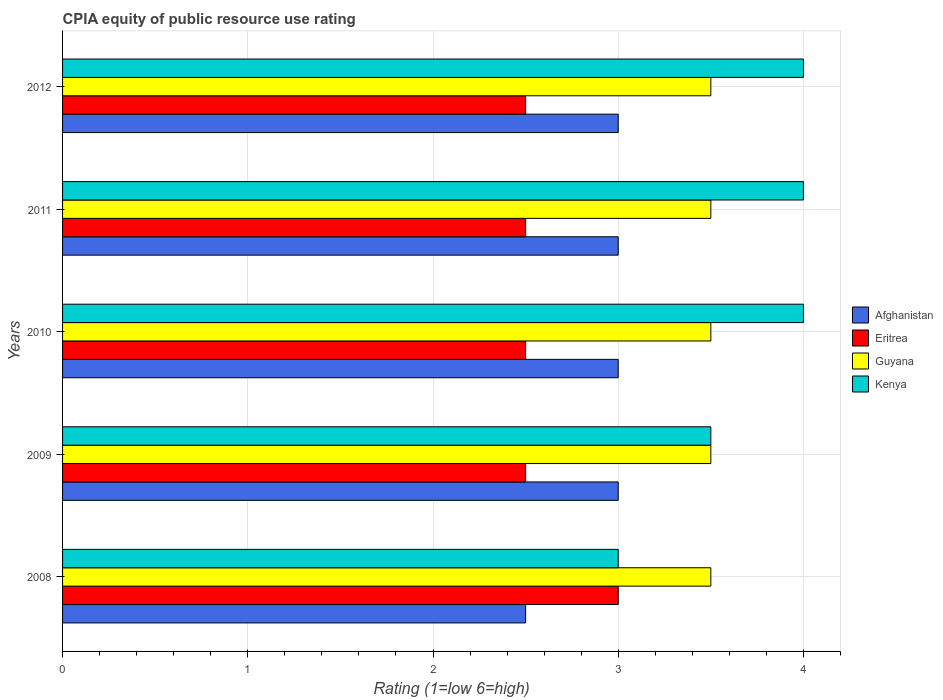How many groups of bars are there?
Provide a short and direct response. 5. Are the number of bars per tick equal to the number of legend labels?
Provide a succinct answer. Yes. What is the label of the 3rd group of bars from the top?
Ensure brevity in your answer.  2010. In how many cases, is the number of bars for a given year not equal to the number of legend labels?
Your response must be concise. 0. Across all years, what is the maximum CPIA rating in Guyana?
Provide a short and direct response. 3.5. In which year was the CPIA rating in Afghanistan minimum?
Your answer should be compact. 2008. What is the difference between the CPIA rating in Guyana in 2010 and the CPIA rating in Eritrea in 2008?
Provide a succinct answer. 0.5. In the year 2008, what is the difference between the CPIA rating in Guyana and CPIA rating in Kenya?
Your response must be concise. 0.5. What is the difference between the highest and the lowest CPIA rating in Kenya?
Ensure brevity in your answer.  1. Is the sum of the CPIA rating in Guyana in 2010 and 2011 greater than the maximum CPIA rating in Afghanistan across all years?
Your answer should be compact. Yes. What does the 2nd bar from the top in 2008 represents?
Offer a terse response. Guyana. What does the 2nd bar from the bottom in 2012 represents?
Your answer should be very brief. Eritrea. Is it the case that in every year, the sum of the CPIA rating in Eritrea and CPIA rating in Afghanistan is greater than the CPIA rating in Guyana?
Your answer should be very brief. Yes. What is the difference between two consecutive major ticks on the X-axis?
Ensure brevity in your answer.  1. Does the graph contain grids?
Your response must be concise. Yes. What is the title of the graph?
Your answer should be compact. CPIA equity of public resource use rating. What is the label or title of the Y-axis?
Keep it short and to the point. Years. What is the Rating (1=low 6=high) of Afghanistan in 2008?
Offer a terse response. 2.5. What is the Rating (1=low 6=high) in Eritrea in 2008?
Your answer should be compact. 3. What is the Rating (1=low 6=high) of Guyana in 2009?
Provide a succinct answer. 3.5. What is the Rating (1=low 6=high) of Guyana in 2010?
Offer a very short reply. 3.5. What is the Rating (1=low 6=high) in Guyana in 2011?
Ensure brevity in your answer.  3.5. What is the Rating (1=low 6=high) in Kenya in 2011?
Ensure brevity in your answer.  4. What is the Rating (1=low 6=high) in Afghanistan in 2012?
Provide a short and direct response. 3. What is the Rating (1=low 6=high) in Eritrea in 2012?
Give a very brief answer. 2.5. What is the Rating (1=low 6=high) of Guyana in 2012?
Provide a short and direct response. 3.5. Across all years, what is the maximum Rating (1=low 6=high) of Afghanistan?
Give a very brief answer. 3. Across all years, what is the minimum Rating (1=low 6=high) of Guyana?
Offer a very short reply. 3.5. Across all years, what is the minimum Rating (1=low 6=high) in Kenya?
Give a very brief answer. 3. What is the total Rating (1=low 6=high) of Afghanistan in the graph?
Offer a terse response. 14.5. What is the total Rating (1=low 6=high) in Eritrea in the graph?
Your response must be concise. 13. What is the difference between the Rating (1=low 6=high) in Afghanistan in 2008 and that in 2009?
Provide a succinct answer. -0.5. What is the difference between the Rating (1=low 6=high) in Kenya in 2008 and that in 2009?
Your answer should be compact. -0.5. What is the difference between the Rating (1=low 6=high) in Eritrea in 2008 and that in 2010?
Provide a short and direct response. 0.5. What is the difference between the Rating (1=low 6=high) of Kenya in 2008 and that in 2010?
Your answer should be compact. -1. What is the difference between the Rating (1=low 6=high) in Afghanistan in 2008 and that in 2011?
Offer a terse response. -0.5. What is the difference between the Rating (1=low 6=high) of Eritrea in 2008 and that in 2011?
Offer a very short reply. 0.5. What is the difference between the Rating (1=low 6=high) in Guyana in 2008 and that in 2011?
Ensure brevity in your answer.  0. What is the difference between the Rating (1=low 6=high) of Kenya in 2008 and that in 2011?
Give a very brief answer. -1. What is the difference between the Rating (1=low 6=high) in Afghanistan in 2009 and that in 2011?
Give a very brief answer. 0. What is the difference between the Rating (1=low 6=high) of Guyana in 2009 and that in 2011?
Your answer should be compact. 0. What is the difference between the Rating (1=low 6=high) in Afghanistan in 2010 and that in 2011?
Ensure brevity in your answer.  0. What is the difference between the Rating (1=low 6=high) in Eritrea in 2010 and that in 2011?
Keep it short and to the point. 0. What is the difference between the Rating (1=low 6=high) of Guyana in 2010 and that in 2011?
Make the answer very short. 0. What is the difference between the Rating (1=low 6=high) of Kenya in 2010 and that in 2011?
Keep it short and to the point. 0. What is the difference between the Rating (1=low 6=high) in Afghanistan in 2010 and that in 2012?
Provide a succinct answer. 0. What is the difference between the Rating (1=low 6=high) in Guyana in 2010 and that in 2012?
Ensure brevity in your answer.  0. What is the difference between the Rating (1=low 6=high) in Kenya in 2010 and that in 2012?
Offer a very short reply. 0. What is the difference between the Rating (1=low 6=high) in Afghanistan in 2011 and that in 2012?
Your answer should be compact. 0. What is the difference between the Rating (1=low 6=high) of Eritrea in 2011 and that in 2012?
Offer a very short reply. 0. What is the difference between the Rating (1=low 6=high) of Afghanistan in 2008 and the Rating (1=low 6=high) of Eritrea in 2009?
Your answer should be compact. 0. What is the difference between the Rating (1=low 6=high) of Eritrea in 2008 and the Rating (1=low 6=high) of Guyana in 2009?
Your response must be concise. -0.5. What is the difference between the Rating (1=low 6=high) of Afghanistan in 2008 and the Rating (1=low 6=high) of Guyana in 2010?
Offer a terse response. -1. What is the difference between the Rating (1=low 6=high) in Eritrea in 2008 and the Rating (1=low 6=high) in Kenya in 2010?
Provide a succinct answer. -1. What is the difference between the Rating (1=low 6=high) in Guyana in 2008 and the Rating (1=low 6=high) in Kenya in 2010?
Offer a terse response. -0.5. What is the difference between the Rating (1=low 6=high) of Afghanistan in 2008 and the Rating (1=low 6=high) of Eritrea in 2011?
Provide a succinct answer. 0. What is the difference between the Rating (1=low 6=high) of Afghanistan in 2008 and the Rating (1=low 6=high) of Eritrea in 2012?
Your response must be concise. 0. What is the difference between the Rating (1=low 6=high) in Afghanistan in 2008 and the Rating (1=low 6=high) in Kenya in 2012?
Make the answer very short. -1.5. What is the difference between the Rating (1=low 6=high) of Eritrea in 2008 and the Rating (1=low 6=high) of Guyana in 2012?
Your answer should be very brief. -0.5. What is the difference between the Rating (1=low 6=high) of Eritrea in 2008 and the Rating (1=low 6=high) of Kenya in 2012?
Your response must be concise. -1. What is the difference between the Rating (1=low 6=high) of Guyana in 2008 and the Rating (1=low 6=high) of Kenya in 2012?
Your response must be concise. -0.5. What is the difference between the Rating (1=low 6=high) in Afghanistan in 2009 and the Rating (1=low 6=high) in Eritrea in 2010?
Your answer should be very brief. 0.5. What is the difference between the Rating (1=low 6=high) in Afghanistan in 2009 and the Rating (1=low 6=high) in Kenya in 2010?
Provide a succinct answer. -1. What is the difference between the Rating (1=low 6=high) in Eritrea in 2009 and the Rating (1=low 6=high) in Guyana in 2010?
Your answer should be very brief. -1. What is the difference between the Rating (1=low 6=high) in Eritrea in 2009 and the Rating (1=low 6=high) in Kenya in 2010?
Your response must be concise. -1.5. What is the difference between the Rating (1=low 6=high) of Afghanistan in 2009 and the Rating (1=low 6=high) of Kenya in 2011?
Offer a terse response. -1. What is the difference between the Rating (1=low 6=high) in Guyana in 2009 and the Rating (1=low 6=high) in Kenya in 2011?
Offer a very short reply. -0.5. What is the difference between the Rating (1=low 6=high) of Afghanistan in 2009 and the Rating (1=low 6=high) of Eritrea in 2012?
Give a very brief answer. 0.5. What is the difference between the Rating (1=low 6=high) in Afghanistan in 2009 and the Rating (1=low 6=high) in Kenya in 2012?
Give a very brief answer. -1. What is the difference between the Rating (1=low 6=high) in Afghanistan in 2010 and the Rating (1=low 6=high) in Guyana in 2011?
Your answer should be compact. -0.5. What is the difference between the Rating (1=low 6=high) of Afghanistan in 2010 and the Rating (1=low 6=high) of Kenya in 2011?
Your answer should be compact. -1. What is the difference between the Rating (1=low 6=high) in Eritrea in 2010 and the Rating (1=low 6=high) in Guyana in 2011?
Your answer should be compact. -1. What is the difference between the Rating (1=low 6=high) in Afghanistan in 2010 and the Rating (1=low 6=high) in Eritrea in 2012?
Offer a very short reply. 0.5. What is the difference between the Rating (1=low 6=high) in Afghanistan in 2010 and the Rating (1=low 6=high) in Guyana in 2012?
Your answer should be very brief. -0.5. What is the difference between the Rating (1=low 6=high) of Afghanistan in 2010 and the Rating (1=low 6=high) of Kenya in 2012?
Your answer should be compact. -1. What is the difference between the Rating (1=low 6=high) in Eritrea in 2010 and the Rating (1=low 6=high) in Guyana in 2012?
Give a very brief answer. -1. What is the difference between the Rating (1=low 6=high) in Eritrea in 2010 and the Rating (1=low 6=high) in Kenya in 2012?
Offer a terse response. -1.5. What is the difference between the Rating (1=low 6=high) in Guyana in 2010 and the Rating (1=low 6=high) in Kenya in 2012?
Your response must be concise. -0.5. What is the difference between the Rating (1=low 6=high) of Afghanistan in 2011 and the Rating (1=low 6=high) of Eritrea in 2012?
Provide a succinct answer. 0.5. What is the difference between the Rating (1=low 6=high) in Afghanistan in 2011 and the Rating (1=low 6=high) in Kenya in 2012?
Your answer should be very brief. -1. What is the average Rating (1=low 6=high) in Eritrea per year?
Your answer should be very brief. 2.6. What is the average Rating (1=low 6=high) in Kenya per year?
Provide a short and direct response. 3.7. In the year 2008, what is the difference between the Rating (1=low 6=high) of Afghanistan and Rating (1=low 6=high) of Eritrea?
Make the answer very short. -0.5. In the year 2008, what is the difference between the Rating (1=low 6=high) in Afghanistan and Rating (1=low 6=high) in Kenya?
Your response must be concise. -0.5. In the year 2008, what is the difference between the Rating (1=low 6=high) in Eritrea and Rating (1=low 6=high) in Guyana?
Your answer should be very brief. -0.5. In the year 2009, what is the difference between the Rating (1=low 6=high) of Afghanistan and Rating (1=low 6=high) of Eritrea?
Your answer should be very brief. 0.5. In the year 2009, what is the difference between the Rating (1=low 6=high) in Eritrea and Rating (1=low 6=high) in Kenya?
Provide a short and direct response. -1. In the year 2010, what is the difference between the Rating (1=low 6=high) in Afghanistan and Rating (1=low 6=high) in Eritrea?
Keep it short and to the point. 0.5. In the year 2010, what is the difference between the Rating (1=low 6=high) in Afghanistan and Rating (1=low 6=high) in Guyana?
Your response must be concise. -0.5. In the year 2010, what is the difference between the Rating (1=low 6=high) of Eritrea and Rating (1=low 6=high) of Guyana?
Offer a terse response. -1. In the year 2011, what is the difference between the Rating (1=low 6=high) of Afghanistan and Rating (1=low 6=high) of Guyana?
Provide a short and direct response. -0.5. In the year 2011, what is the difference between the Rating (1=low 6=high) in Afghanistan and Rating (1=low 6=high) in Kenya?
Your answer should be very brief. -1. In the year 2011, what is the difference between the Rating (1=low 6=high) of Eritrea and Rating (1=low 6=high) of Guyana?
Give a very brief answer. -1. In the year 2012, what is the difference between the Rating (1=low 6=high) in Afghanistan and Rating (1=low 6=high) in Eritrea?
Provide a short and direct response. 0.5. In the year 2012, what is the difference between the Rating (1=low 6=high) of Afghanistan and Rating (1=low 6=high) of Guyana?
Give a very brief answer. -0.5. In the year 2012, what is the difference between the Rating (1=low 6=high) in Afghanistan and Rating (1=low 6=high) in Kenya?
Make the answer very short. -1. In the year 2012, what is the difference between the Rating (1=low 6=high) in Eritrea and Rating (1=low 6=high) in Guyana?
Your response must be concise. -1. In the year 2012, what is the difference between the Rating (1=low 6=high) in Eritrea and Rating (1=low 6=high) in Kenya?
Make the answer very short. -1.5. What is the ratio of the Rating (1=low 6=high) in Afghanistan in 2008 to that in 2009?
Your response must be concise. 0.83. What is the ratio of the Rating (1=low 6=high) in Eritrea in 2008 to that in 2009?
Your answer should be very brief. 1.2. What is the ratio of the Rating (1=low 6=high) of Kenya in 2008 to that in 2009?
Your answer should be very brief. 0.86. What is the ratio of the Rating (1=low 6=high) in Eritrea in 2008 to that in 2010?
Provide a short and direct response. 1.2. What is the ratio of the Rating (1=low 6=high) of Kenya in 2008 to that in 2010?
Ensure brevity in your answer.  0.75. What is the ratio of the Rating (1=low 6=high) in Afghanistan in 2008 to that in 2011?
Offer a very short reply. 0.83. What is the ratio of the Rating (1=low 6=high) of Eritrea in 2008 to that in 2011?
Keep it short and to the point. 1.2. What is the ratio of the Rating (1=low 6=high) of Afghanistan in 2008 to that in 2012?
Provide a short and direct response. 0.83. What is the ratio of the Rating (1=low 6=high) of Guyana in 2008 to that in 2012?
Your answer should be compact. 1. What is the ratio of the Rating (1=low 6=high) in Kenya in 2008 to that in 2012?
Provide a short and direct response. 0.75. What is the ratio of the Rating (1=low 6=high) of Afghanistan in 2009 to that in 2010?
Give a very brief answer. 1. What is the ratio of the Rating (1=low 6=high) in Kenya in 2009 to that in 2010?
Your response must be concise. 0.88. What is the ratio of the Rating (1=low 6=high) of Afghanistan in 2009 to that in 2011?
Your response must be concise. 1. What is the ratio of the Rating (1=low 6=high) of Kenya in 2009 to that in 2011?
Give a very brief answer. 0.88. What is the ratio of the Rating (1=low 6=high) of Guyana in 2009 to that in 2012?
Give a very brief answer. 1. What is the ratio of the Rating (1=low 6=high) in Kenya in 2009 to that in 2012?
Keep it short and to the point. 0.88. What is the ratio of the Rating (1=low 6=high) of Eritrea in 2010 to that in 2011?
Offer a terse response. 1. What is the ratio of the Rating (1=low 6=high) of Guyana in 2010 to that in 2011?
Your answer should be very brief. 1. What is the ratio of the Rating (1=low 6=high) in Kenya in 2010 to that in 2011?
Offer a terse response. 1. What is the ratio of the Rating (1=low 6=high) of Afghanistan in 2010 to that in 2012?
Keep it short and to the point. 1. What is the ratio of the Rating (1=low 6=high) in Eritrea in 2010 to that in 2012?
Your answer should be very brief. 1. What is the ratio of the Rating (1=low 6=high) of Afghanistan in 2011 to that in 2012?
Give a very brief answer. 1. What is the ratio of the Rating (1=low 6=high) in Eritrea in 2011 to that in 2012?
Give a very brief answer. 1. What is the ratio of the Rating (1=low 6=high) in Kenya in 2011 to that in 2012?
Make the answer very short. 1. What is the difference between the highest and the second highest Rating (1=low 6=high) in Eritrea?
Make the answer very short. 0.5. What is the difference between the highest and the second highest Rating (1=low 6=high) in Guyana?
Provide a succinct answer. 0. What is the difference between the highest and the second highest Rating (1=low 6=high) in Kenya?
Your response must be concise. 0. What is the difference between the highest and the lowest Rating (1=low 6=high) of Afghanistan?
Provide a short and direct response. 0.5. What is the difference between the highest and the lowest Rating (1=low 6=high) of Guyana?
Provide a short and direct response. 0. What is the difference between the highest and the lowest Rating (1=low 6=high) in Kenya?
Make the answer very short. 1. 